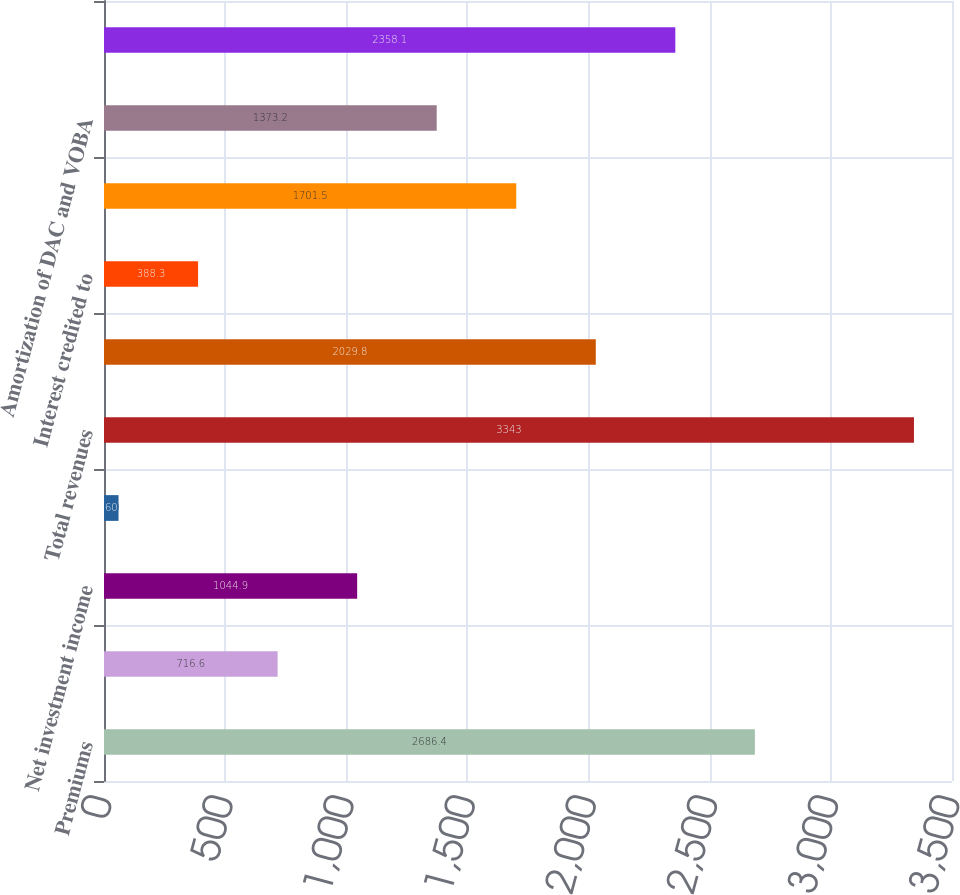Convert chart. <chart><loc_0><loc_0><loc_500><loc_500><bar_chart><fcel>Premiums<fcel>Universal life and<fcel>Net investment income<fcel>Other revenues<fcel>Total revenues<fcel>Policyholder benefits and<fcel>Interest credited to<fcel>Capitalization of DAC<fcel>Amortization of DAC and VOBA<fcel>Other expenses<nl><fcel>2686.4<fcel>716.6<fcel>1044.9<fcel>60<fcel>3343<fcel>2029.8<fcel>388.3<fcel>1701.5<fcel>1373.2<fcel>2358.1<nl></chart> 